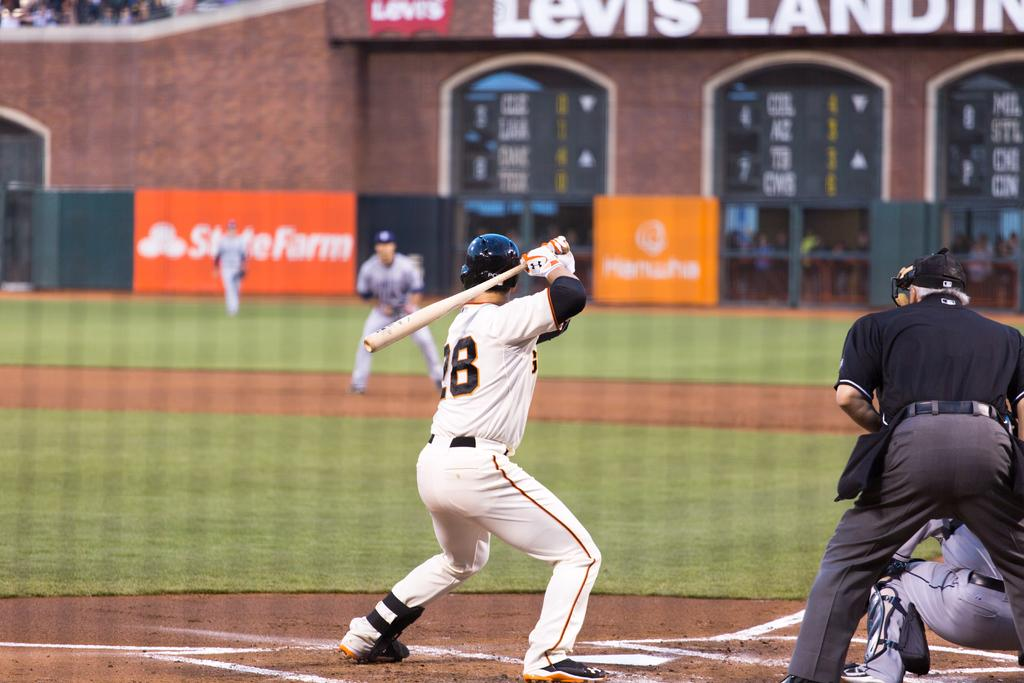<image>
Offer a succinct explanation of the picture presented. A man batting at a baseball game, his number is 28. 